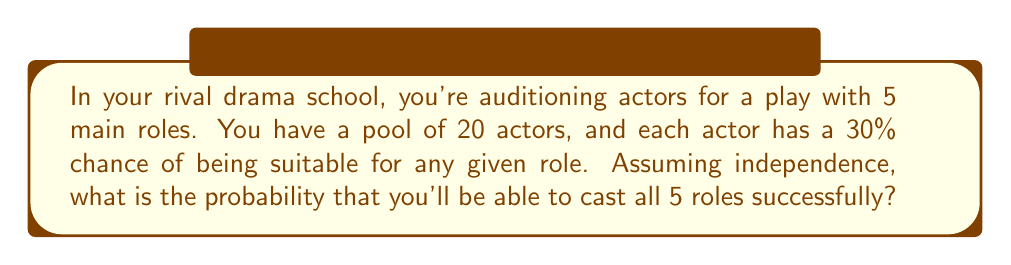Teach me how to tackle this problem. Let's approach this step-by-step:

1) For each role, we need at least one suitable actor out of the 20.

2) The probability of an actor being unsuitable for a role is $1 - 0.3 = 0.7$ or 70%.

3) For a role to go uncast, all 20 actors must be unsuitable. The probability of this is:

   $$(0.7)^{20} = 0.0000798$$

4) Therefore, the probability of successfully casting a single role is:

   $$1 - (0.7)^{20} = 0.9999202$$

5) We need this to happen independently for all 5 roles. So we raise this probability to the power of 5:

   $$(0.9999202)^5 = 0.9996010$$

6) Convert to a percentage:

   $$0.9996010 * 100\% = 99.96010\%$$
Answer: 99.96% 